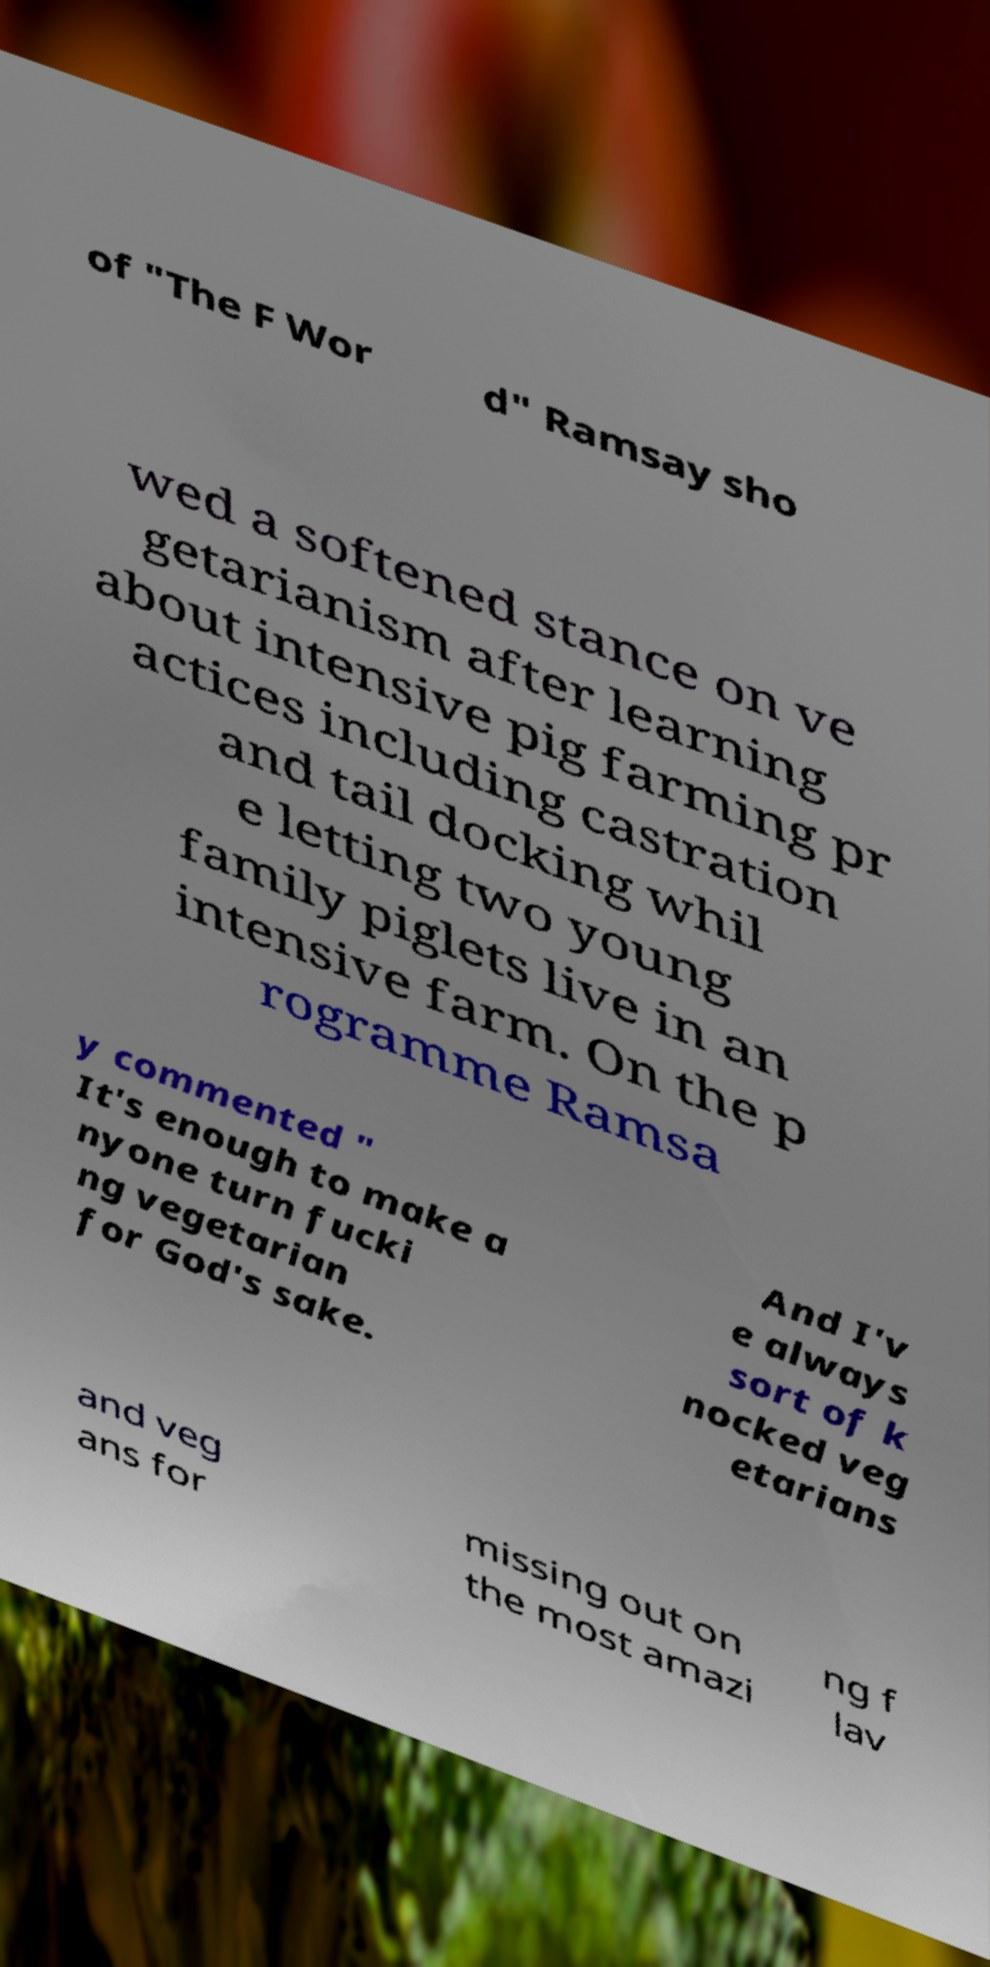Can you read and provide the text displayed in the image?This photo seems to have some interesting text. Can you extract and type it out for me? of "The F Wor d" Ramsay sho wed a softened stance on ve getarianism after learning about intensive pig farming pr actices including castration and tail docking whil e letting two young family piglets live in an intensive farm. On the p rogramme Ramsa y commented " It's enough to make a nyone turn fucki ng vegetarian for God's sake. And I'v e always sort of k nocked veg etarians and veg ans for missing out on the most amazi ng f lav 